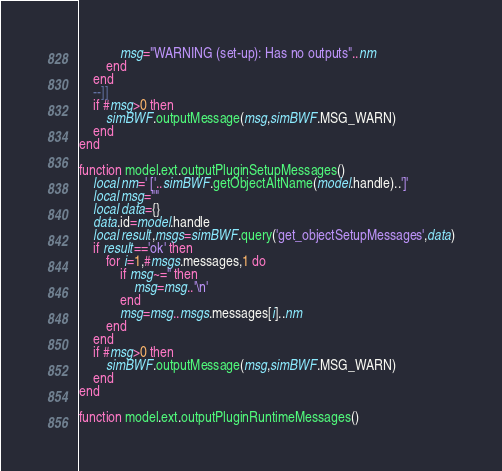Convert code to text. <code><loc_0><loc_0><loc_500><loc_500><_Lua_>            msg="WARNING (set-up): Has no outputs"..nm
        end
    end
    --]]
    if #msg>0 then
        simBWF.outputMessage(msg,simBWF.MSG_WARN)
    end
end

function model.ext.outputPluginSetupMessages()
    local nm=' ['..simBWF.getObjectAltName(model.handle)..']'
    local msg=""
    local data={}
    data.id=model.handle
    local result,msgs=simBWF.query('get_objectSetupMessages',data)
    if result=='ok' then
        for i=1,#msgs.messages,1 do
            if msg~='' then
                msg=msg..'\n'
            end
            msg=msg..msgs.messages[i]..nm
        end
    end
    if #msg>0 then
        simBWF.outputMessage(msg,simBWF.MSG_WARN)
    end
end

function model.ext.outputPluginRuntimeMessages()</code> 